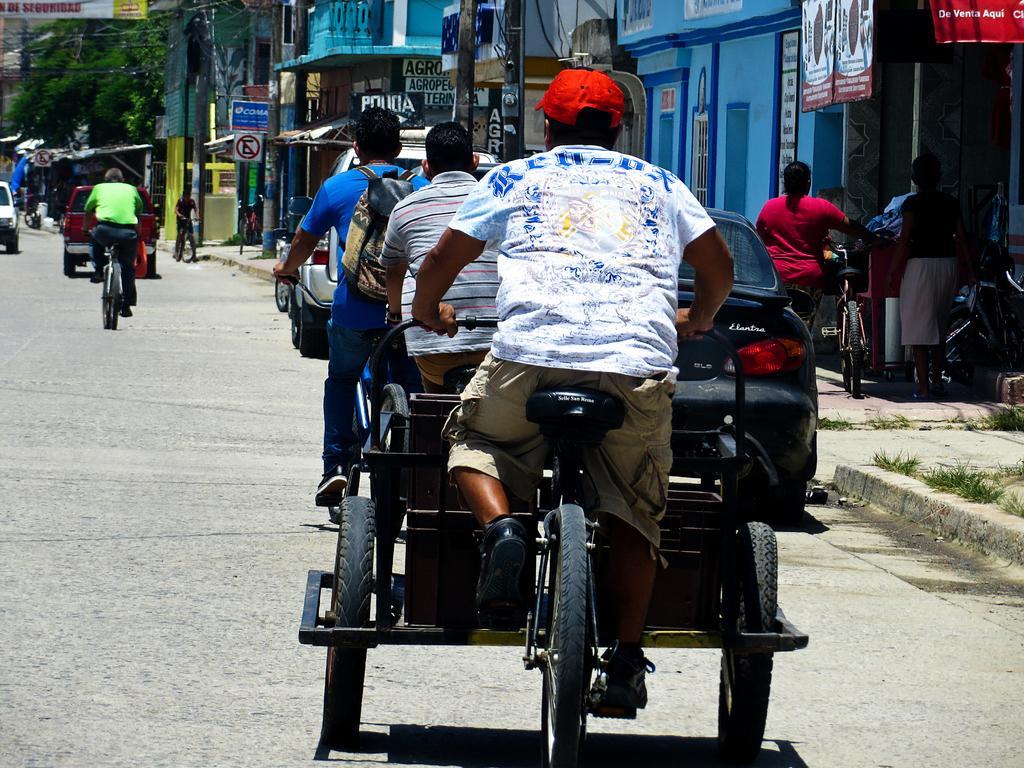Can you describe this image briefly? In the foreground three persons are riding a bicycle. And a woman is standing with a bicycle. In front of that a person is standing. In the middle top left a person is riding a bicycle, in front of that a car is moving. In the background buildings are visible. In the top left, trees are visible. And below that a sign board is visible. This image is taken on the road during day time. 